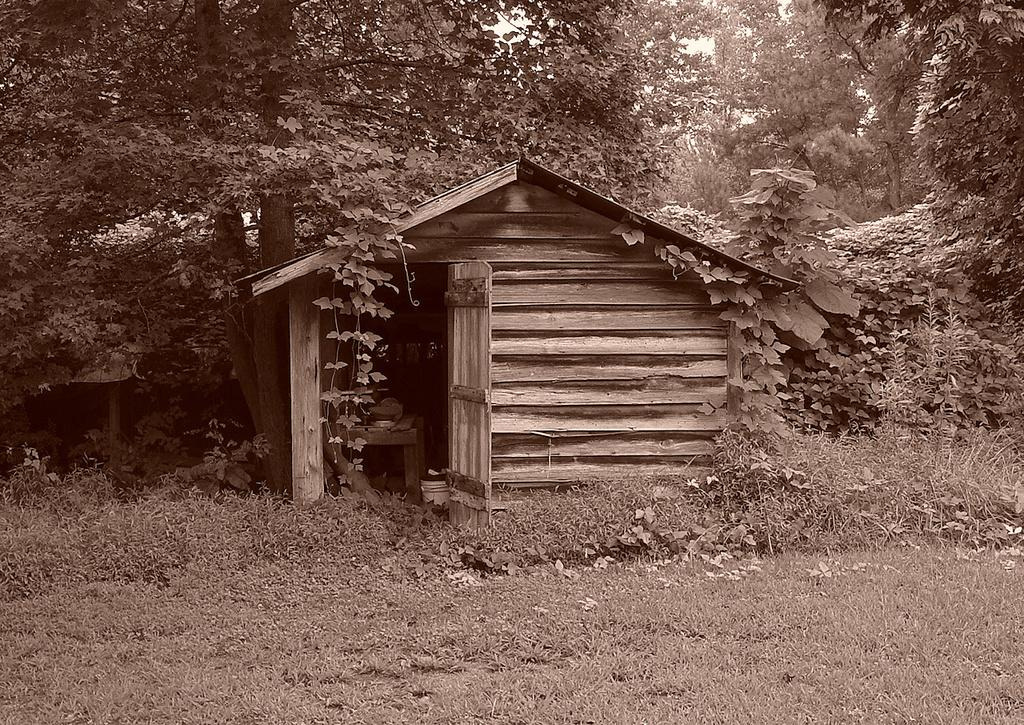What type of house is in the image? There is a wooden house in the image. What can be seen in the background of the image? There are trees in the image. What other types of vegetation are present in the image? There are plants in the image. What covers the ground in the image? There is grass on the ground in the image. What type of heart can be seen beating in the image? There is no heart visible in the image; it is a scene featuring a wooden house, trees, plants, and grass. 